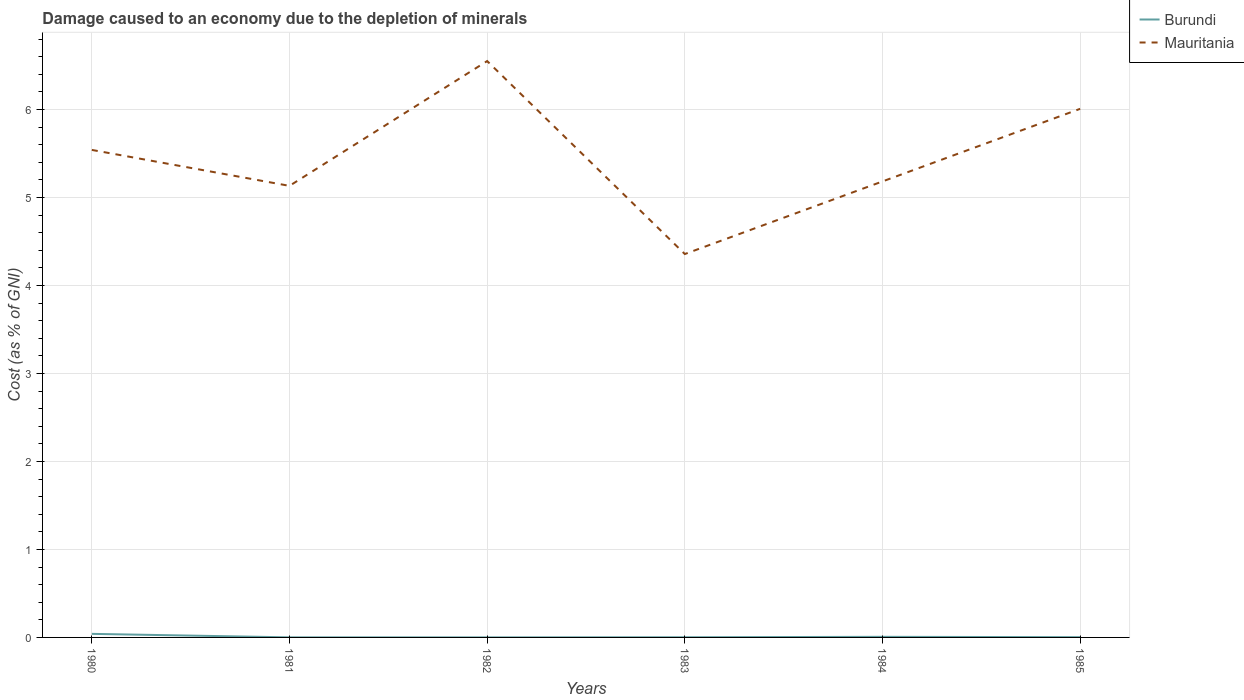Across all years, what is the maximum cost of damage caused due to the depletion of minerals in Mauritania?
Keep it short and to the point. 4.36. What is the total cost of damage caused due to the depletion of minerals in Burundi in the graph?
Offer a terse response. 0.04. What is the difference between the highest and the second highest cost of damage caused due to the depletion of minerals in Burundi?
Make the answer very short. 0.04. What is the difference between the highest and the lowest cost of damage caused due to the depletion of minerals in Burundi?
Your answer should be compact. 1. What is the difference between two consecutive major ticks on the Y-axis?
Keep it short and to the point. 1. Does the graph contain any zero values?
Your answer should be compact. No. Where does the legend appear in the graph?
Your response must be concise. Top right. How many legend labels are there?
Give a very brief answer. 2. How are the legend labels stacked?
Your answer should be very brief. Vertical. What is the title of the graph?
Your answer should be compact. Damage caused to an economy due to the depletion of minerals. Does "France" appear as one of the legend labels in the graph?
Give a very brief answer. No. What is the label or title of the Y-axis?
Ensure brevity in your answer.  Cost (as % of GNI). What is the Cost (as % of GNI) in Burundi in 1980?
Provide a succinct answer. 0.04. What is the Cost (as % of GNI) of Mauritania in 1980?
Give a very brief answer. 5.54. What is the Cost (as % of GNI) of Burundi in 1981?
Give a very brief answer. 0. What is the Cost (as % of GNI) in Mauritania in 1981?
Your answer should be compact. 5.13. What is the Cost (as % of GNI) in Burundi in 1982?
Your response must be concise. 0. What is the Cost (as % of GNI) of Mauritania in 1982?
Offer a very short reply. 6.55. What is the Cost (as % of GNI) of Burundi in 1983?
Your answer should be very brief. 0. What is the Cost (as % of GNI) of Mauritania in 1983?
Provide a succinct answer. 4.36. What is the Cost (as % of GNI) in Burundi in 1984?
Make the answer very short. 0.01. What is the Cost (as % of GNI) in Mauritania in 1984?
Provide a short and direct response. 5.18. What is the Cost (as % of GNI) in Burundi in 1985?
Offer a terse response. 0. What is the Cost (as % of GNI) in Mauritania in 1985?
Ensure brevity in your answer.  6.01. Across all years, what is the maximum Cost (as % of GNI) of Burundi?
Keep it short and to the point. 0.04. Across all years, what is the maximum Cost (as % of GNI) in Mauritania?
Give a very brief answer. 6.55. Across all years, what is the minimum Cost (as % of GNI) in Burundi?
Your response must be concise. 0. Across all years, what is the minimum Cost (as % of GNI) in Mauritania?
Give a very brief answer. 4.36. What is the total Cost (as % of GNI) in Burundi in the graph?
Provide a short and direct response. 0.05. What is the total Cost (as % of GNI) in Mauritania in the graph?
Your response must be concise. 32.77. What is the difference between the Cost (as % of GNI) of Burundi in 1980 and that in 1981?
Keep it short and to the point. 0.04. What is the difference between the Cost (as % of GNI) of Mauritania in 1980 and that in 1981?
Ensure brevity in your answer.  0.41. What is the difference between the Cost (as % of GNI) of Burundi in 1980 and that in 1982?
Offer a terse response. 0.04. What is the difference between the Cost (as % of GNI) of Mauritania in 1980 and that in 1982?
Provide a short and direct response. -1.01. What is the difference between the Cost (as % of GNI) in Burundi in 1980 and that in 1983?
Your response must be concise. 0.04. What is the difference between the Cost (as % of GNI) in Mauritania in 1980 and that in 1983?
Your answer should be compact. 1.18. What is the difference between the Cost (as % of GNI) of Burundi in 1980 and that in 1984?
Give a very brief answer. 0.03. What is the difference between the Cost (as % of GNI) of Mauritania in 1980 and that in 1984?
Your response must be concise. 0.36. What is the difference between the Cost (as % of GNI) of Burundi in 1980 and that in 1985?
Give a very brief answer. 0.04. What is the difference between the Cost (as % of GNI) in Mauritania in 1980 and that in 1985?
Your response must be concise. -0.47. What is the difference between the Cost (as % of GNI) in Mauritania in 1981 and that in 1982?
Your answer should be compact. -1.42. What is the difference between the Cost (as % of GNI) of Burundi in 1981 and that in 1983?
Your answer should be compact. -0. What is the difference between the Cost (as % of GNI) of Mauritania in 1981 and that in 1983?
Offer a very short reply. 0.77. What is the difference between the Cost (as % of GNI) in Burundi in 1981 and that in 1984?
Give a very brief answer. -0.01. What is the difference between the Cost (as % of GNI) in Mauritania in 1981 and that in 1984?
Your response must be concise. -0.05. What is the difference between the Cost (as % of GNI) of Burundi in 1981 and that in 1985?
Your answer should be very brief. -0. What is the difference between the Cost (as % of GNI) in Mauritania in 1981 and that in 1985?
Your answer should be compact. -0.88. What is the difference between the Cost (as % of GNI) in Burundi in 1982 and that in 1983?
Keep it short and to the point. -0. What is the difference between the Cost (as % of GNI) in Mauritania in 1982 and that in 1983?
Your answer should be compact. 2.19. What is the difference between the Cost (as % of GNI) in Burundi in 1982 and that in 1984?
Ensure brevity in your answer.  -0.01. What is the difference between the Cost (as % of GNI) of Mauritania in 1982 and that in 1984?
Your answer should be compact. 1.37. What is the difference between the Cost (as % of GNI) of Burundi in 1982 and that in 1985?
Make the answer very short. -0. What is the difference between the Cost (as % of GNI) in Mauritania in 1982 and that in 1985?
Ensure brevity in your answer.  0.54. What is the difference between the Cost (as % of GNI) in Burundi in 1983 and that in 1984?
Offer a terse response. -0. What is the difference between the Cost (as % of GNI) in Mauritania in 1983 and that in 1984?
Your answer should be very brief. -0.83. What is the difference between the Cost (as % of GNI) of Burundi in 1983 and that in 1985?
Provide a succinct answer. -0. What is the difference between the Cost (as % of GNI) in Mauritania in 1983 and that in 1985?
Ensure brevity in your answer.  -1.65. What is the difference between the Cost (as % of GNI) in Burundi in 1984 and that in 1985?
Provide a succinct answer. 0. What is the difference between the Cost (as % of GNI) in Mauritania in 1984 and that in 1985?
Offer a very short reply. -0.82. What is the difference between the Cost (as % of GNI) in Burundi in 1980 and the Cost (as % of GNI) in Mauritania in 1981?
Make the answer very short. -5.09. What is the difference between the Cost (as % of GNI) in Burundi in 1980 and the Cost (as % of GNI) in Mauritania in 1982?
Keep it short and to the point. -6.51. What is the difference between the Cost (as % of GNI) of Burundi in 1980 and the Cost (as % of GNI) of Mauritania in 1983?
Offer a very short reply. -4.32. What is the difference between the Cost (as % of GNI) in Burundi in 1980 and the Cost (as % of GNI) in Mauritania in 1984?
Provide a short and direct response. -5.14. What is the difference between the Cost (as % of GNI) of Burundi in 1980 and the Cost (as % of GNI) of Mauritania in 1985?
Provide a succinct answer. -5.97. What is the difference between the Cost (as % of GNI) in Burundi in 1981 and the Cost (as % of GNI) in Mauritania in 1982?
Provide a succinct answer. -6.55. What is the difference between the Cost (as % of GNI) in Burundi in 1981 and the Cost (as % of GNI) in Mauritania in 1983?
Give a very brief answer. -4.36. What is the difference between the Cost (as % of GNI) in Burundi in 1981 and the Cost (as % of GNI) in Mauritania in 1984?
Your response must be concise. -5.18. What is the difference between the Cost (as % of GNI) of Burundi in 1981 and the Cost (as % of GNI) of Mauritania in 1985?
Your answer should be compact. -6.01. What is the difference between the Cost (as % of GNI) of Burundi in 1982 and the Cost (as % of GNI) of Mauritania in 1983?
Keep it short and to the point. -4.36. What is the difference between the Cost (as % of GNI) in Burundi in 1982 and the Cost (as % of GNI) in Mauritania in 1984?
Provide a short and direct response. -5.18. What is the difference between the Cost (as % of GNI) of Burundi in 1982 and the Cost (as % of GNI) of Mauritania in 1985?
Offer a terse response. -6.01. What is the difference between the Cost (as % of GNI) in Burundi in 1983 and the Cost (as % of GNI) in Mauritania in 1984?
Make the answer very short. -5.18. What is the difference between the Cost (as % of GNI) of Burundi in 1983 and the Cost (as % of GNI) of Mauritania in 1985?
Ensure brevity in your answer.  -6. What is the difference between the Cost (as % of GNI) of Burundi in 1984 and the Cost (as % of GNI) of Mauritania in 1985?
Your response must be concise. -6. What is the average Cost (as % of GNI) in Burundi per year?
Your answer should be very brief. 0.01. What is the average Cost (as % of GNI) of Mauritania per year?
Ensure brevity in your answer.  5.46. In the year 1980, what is the difference between the Cost (as % of GNI) in Burundi and Cost (as % of GNI) in Mauritania?
Your response must be concise. -5.5. In the year 1981, what is the difference between the Cost (as % of GNI) in Burundi and Cost (as % of GNI) in Mauritania?
Offer a terse response. -5.13. In the year 1982, what is the difference between the Cost (as % of GNI) of Burundi and Cost (as % of GNI) of Mauritania?
Offer a very short reply. -6.55. In the year 1983, what is the difference between the Cost (as % of GNI) in Burundi and Cost (as % of GNI) in Mauritania?
Provide a succinct answer. -4.35. In the year 1984, what is the difference between the Cost (as % of GNI) in Burundi and Cost (as % of GNI) in Mauritania?
Offer a very short reply. -5.18. In the year 1985, what is the difference between the Cost (as % of GNI) of Burundi and Cost (as % of GNI) of Mauritania?
Provide a succinct answer. -6. What is the ratio of the Cost (as % of GNI) in Burundi in 1980 to that in 1981?
Make the answer very short. 43.15. What is the ratio of the Cost (as % of GNI) of Mauritania in 1980 to that in 1981?
Provide a succinct answer. 1.08. What is the ratio of the Cost (as % of GNI) in Burundi in 1980 to that in 1982?
Ensure brevity in your answer.  70.49. What is the ratio of the Cost (as % of GNI) of Mauritania in 1980 to that in 1982?
Your answer should be very brief. 0.85. What is the ratio of the Cost (as % of GNI) of Burundi in 1980 to that in 1983?
Offer a terse response. 20.23. What is the ratio of the Cost (as % of GNI) in Mauritania in 1980 to that in 1983?
Give a very brief answer. 1.27. What is the ratio of the Cost (as % of GNI) of Burundi in 1980 to that in 1984?
Provide a short and direct response. 6.02. What is the ratio of the Cost (as % of GNI) of Mauritania in 1980 to that in 1984?
Your response must be concise. 1.07. What is the ratio of the Cost (as % of GNI) of Burundi in 1980 to that in 1985?
Keep it short and to the point. 13.59. What is the ratio of the Cost (as % of GNI) in Mauritania in 1980 to that in 1985?
Your response must be concise. 0.92. What is the ratio of the Cost (as % of GNI) in Burundi in 1981 to that in 1982?
Offer a very short reply. 1.63. What is the ratio of the Cost (as % of GNI) in Mauritania in 1981 to that in 1982?
Your answer should be very brief. 0.78. What is the ratio of the Cost (as % of GNI) of Burundi in 1981 to that in 1983?
Offer a terse response. 0.47. What is the ratio of the Cost (as % of GNI) of Mauritania in 1981 to that in 1983?
Make the answer very short. 1.18. What is the ratio of the Cost (as % of GNI) in Burundi in 1981 to that in 1984?
Provide a short and direct response. 0.14. What is the ratio of the Cost (as % of GNI) in Mauritania in 1981 to that in 1984?
Offer a terse response. 0.99. What is the ratio of the Cost (as % of GNI) of Burundi in 1981 to that in 1985?
Ensure brevity in your answer.  0.32. What is the ratio of the Cost (as % of GNI) of Mauritania in 1981 to that in 1985?
Make the answer very short. 0.85. What is the ratio of the Cost (as % of GNI) in Burundi in 1982 to that in 1983?
Give a very brief answer. 0.29. What is the ratio of the Cost (as % of GNI) in Mauritania in 1982 to that in 1983?
Offer a terse response. 1.5. What is the ratio of the Cost (as % of GNI) in Burundi in 1982 to that in 1984?
Your response must be concise. 0.09. What is the ratio of the Cost (as % of GNI) in Mauritania in 1982 to that in 1984?
Provide a succinct answer. 1.26. What is the ratio of the Cost (as % of GNI) of Burundi in 1982 to that in 1985?
Give a very brief answer. 0.19. What is the ratio of the Cost (as % of GNI) in Mauritania in 1982 to that in 1985?
Keep it short and to the point. 1.09. What is the ratio of the Cost (as % of GNI) in Burundi in 1983 to that in 1984?
Your response must be concise. 0.3. What is the ratio of the Cost (as % of GNI) in Mauritania in 1983 to that in 1984?
Give a very brief answer. 0.84. What is the ratio of the Cost (as % of GNI) in Burundi in 1983 to that in 1985?
Offer a very short reply. 0.67. What is the ratio of the Cost (as % of GNI) of Mauritania in 1983 to that in 1985?
Provide a short and direct response. 0.73. What is the ratio of the Cost (as % of GNI) of Burundi in 1984 to that in 1985?
Offer a terse response. 2.26. What is the ratio of the Cost (as % of GNI) in Mauritania in 1984 to that in 1985?
Ensure brevity in your answer.  0.86. What is the difference between the highest and the second highest Cost (as % of GNI) of Burundi?
Your response must be concise. 0.03. What is the difference between the highest and the second highest Cost (as % of GNI) in Mauritania?
Your answer should be compact. 0.54. What is the difference between the highest and the lowest Cost (as % of GNI) in Burundi?
Your answer should be very brief. 0.04. What is the difference between the highest and the lowest Cost (as % of GNI) in Mauritania?
Your answer should be very brief. 2.19. 